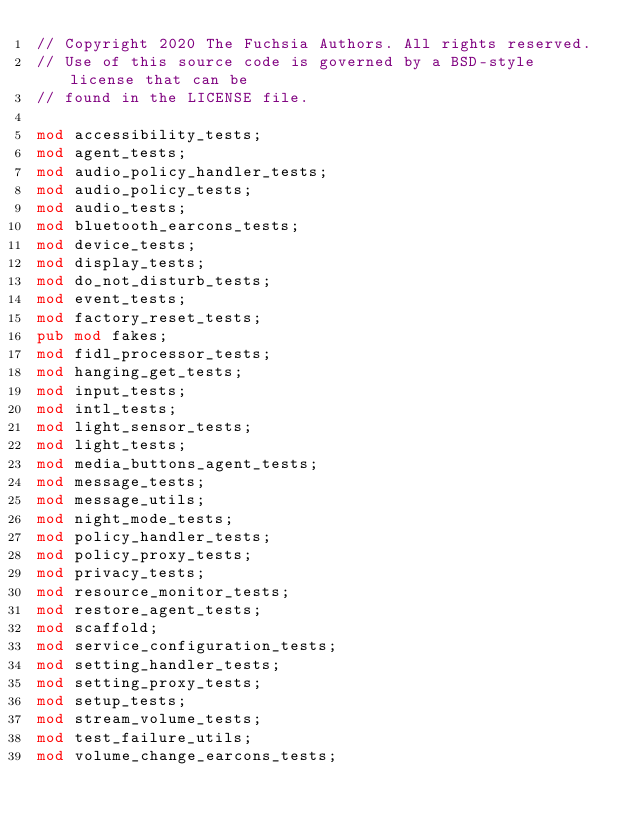<code> <loc_0><loc_0><loc_500><loc_500><_Rust_>// Copyright 2020 The Fuchsia Authors. All rights reserved.
// Use of this source code is governed by a BSD-style license that can be
// found in the LICENSE file.

mod accessibility_tests;
mod agent_tests;
mod audio_policy_handler_tests;
mod audio_policy_tests;
mod audio_tests;
mod bluetooth_earcons_tests;
mod device_tests;
mod display_tests;
mod do_not_disturb_tests;
mod event_tests;
mod factory_reset_tests;
pub mod fakes;
mod fidl_processor_tests;
mod hanging_get_tests;
mod input_tests;
mod intl_tests;
mod light_sensor_tests;
mod light_tests;
mod media_buttons_agent_tests;
mod message_tests;
mod message_utils;
mod night_mode_tests;
mod policy_handler_tests;
mod policy_proxy_tests;
mod privacy_tests;
mod resource_monitor_tests;
mod restore_agent_tests;
mod scaffold;
mod service_configuration_tests;
mod setting_handler_tests;
mod setting_proxy_tests;
mod setup_tests;
mod stream_volume_tests;
mod test_failure_utils;
mod volume_change_earcons_tests;
</code> 